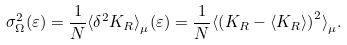Convert formula to latex. <formula><loc_0><loc_0><loc_500><loc_500>\sigma ^ { 2 } _ { \Omega } ( \varepsilon ) = \frac { 1 } { N } \langle \delta ^ { 2 } K _ { R } \rangle ^ { \, } _ { \mu } ( \varepsilon ) = \frac { 1 } { N } \langle \left ( K _ { R } - \langle K _ { R } \rangle \right ) ^ { 2 } \rangle ^ { \, } _ { \mu } .</formula> 